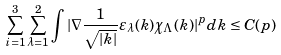Convert formula to latex. <formula><loc_0><loc_0><loc_500><loc_500>\sum _ { i = 1 } ^ { 3 } \sum _ { \lambda = 1 } ^ { 2 } \int | \nabla \frac { 1 } { \sqrt { | k | } } \varepsilon _ { \lambda } ( k ) \chi _ { \Lambda } ( k ) | ^ { p } d k \leq C ( p )</formula> 